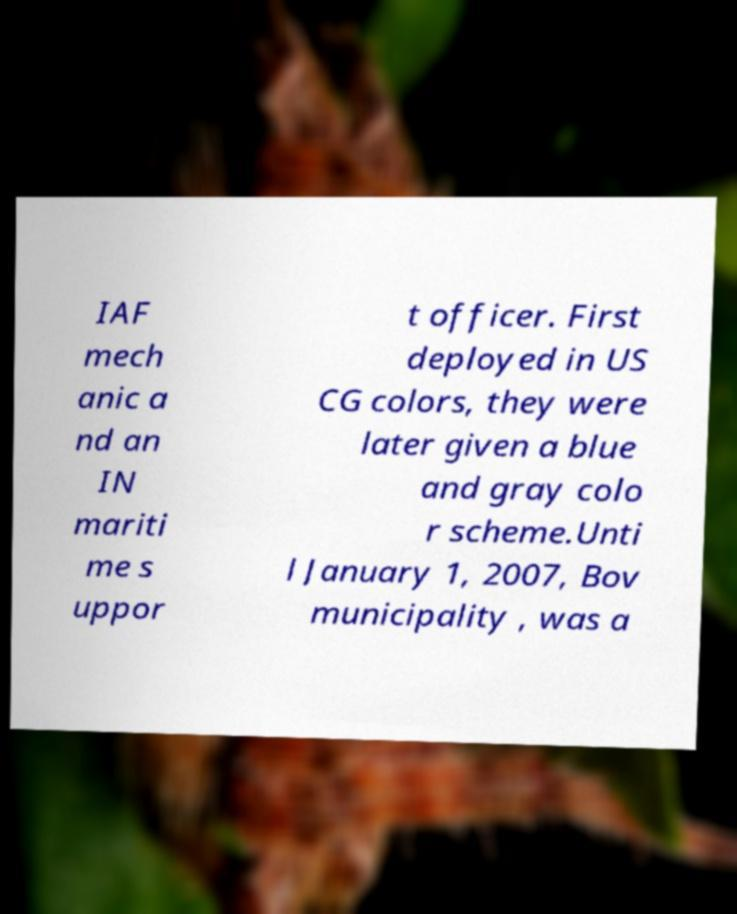Please read and relay the text visible in this image. What does it say? IAF mech anic a nd an IN mariti me s uppor t officer. First deployed in US CG colors, they were later given a blue and gray colo r scheme.Unti l January 1, 2007, Bov municipality , was a 